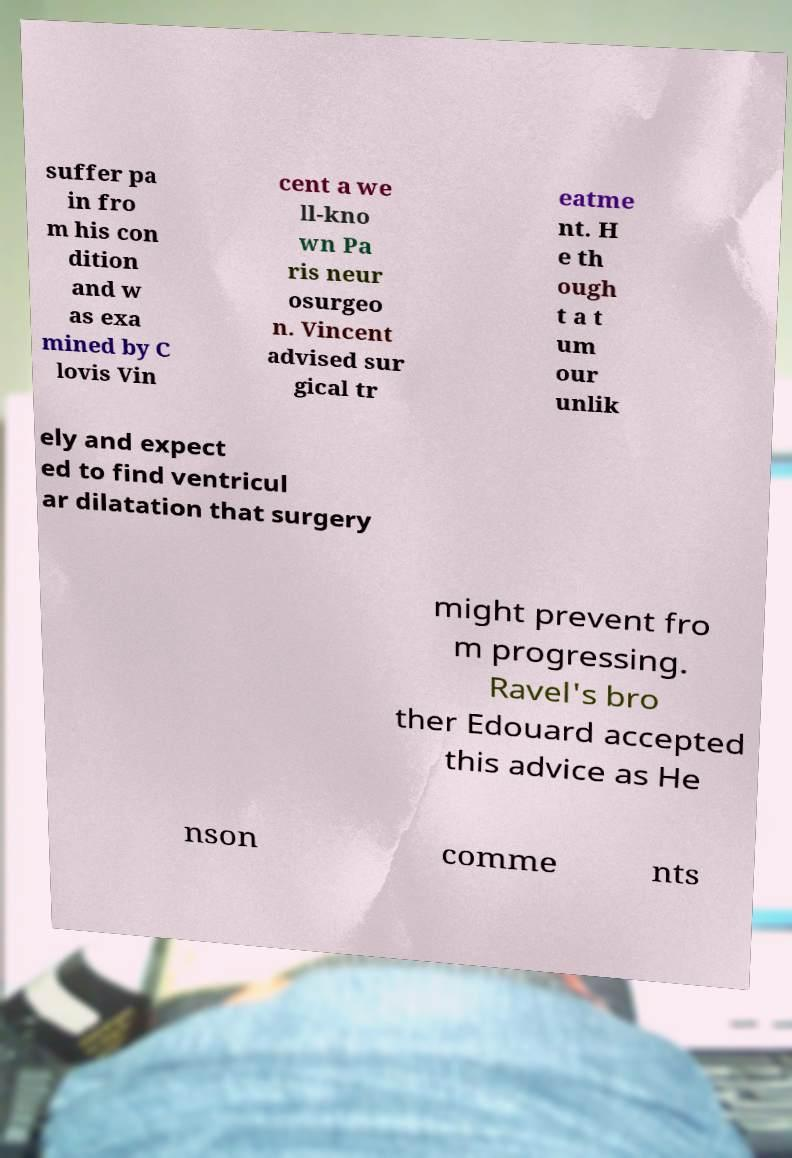Could you assist in decoding the text presented in this image and type it out clearly? suffer pa in fro m his con dition and w as exa mined by C lovis Vin cent a we ll-kno wn Pa ris neur osurgeo n. Vincent advised sur gical tr eatme nt. H e th ough t a t um our unlik ely and expect ed to find ventricul ar dilatation that surgery might prevent fro m progressing. Ravel's bro ther Edouard accepted this advice as He nson comme nts 